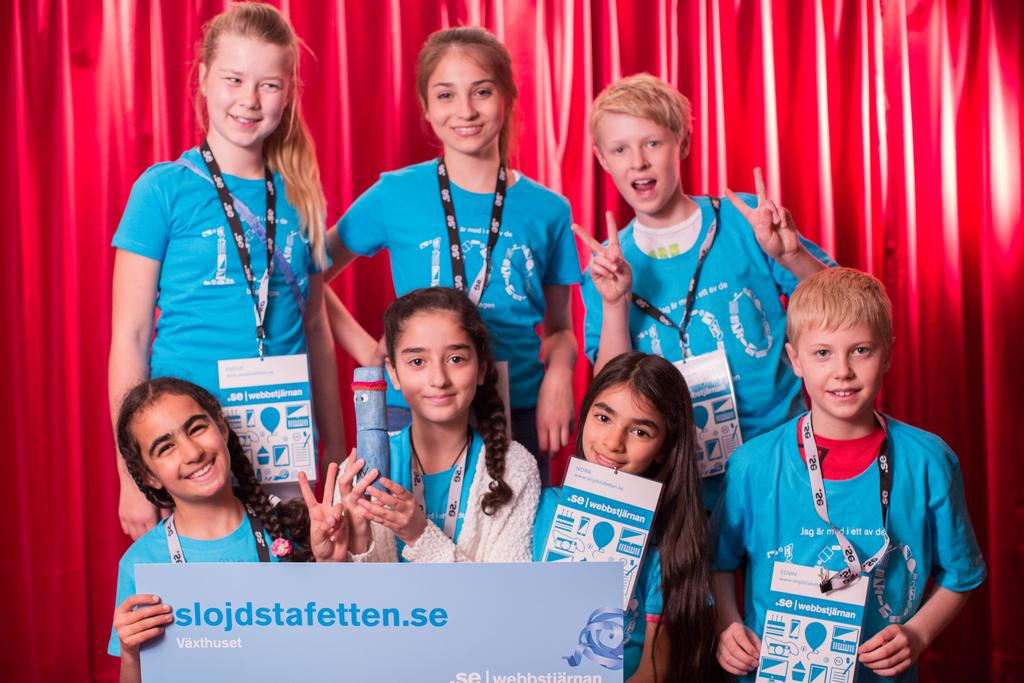What is in the backdrop of the image? There is a curtain in the backdrop of the image. Who is present in the image? There are girls and boys in the image. What are the girls and boys wearing? The girls and boys are wearing blue t-shirts. What expression do the girls and boys have in the image? The girls and boys are smiling. Can you see any cattle in the image? No, there are no cattle present in the image. Are the girls and boys riding skateboards in the image? No, there are no skateboards or any indication of skateboarding in the image. 